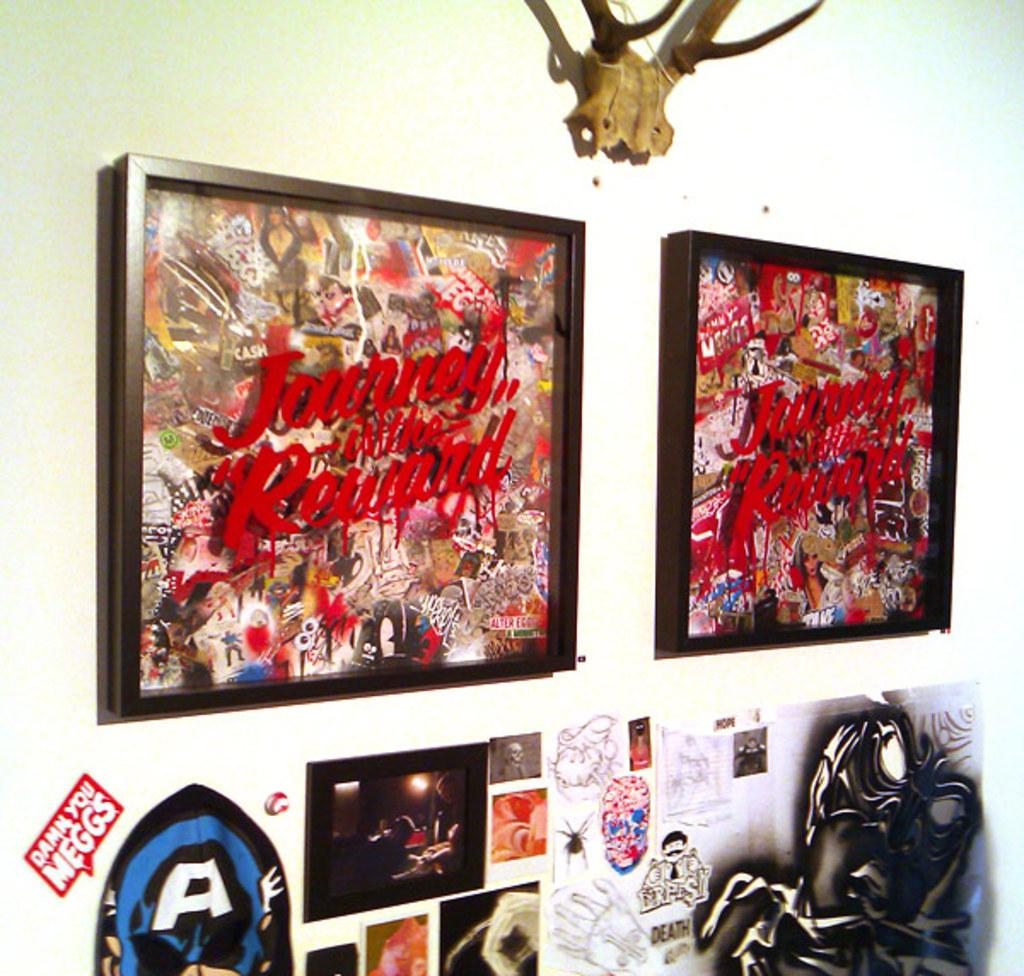<image>
Relay a brief, clear account of the picture shown. Posters and stickers on a wall including one that says "Damn You Meggs". 